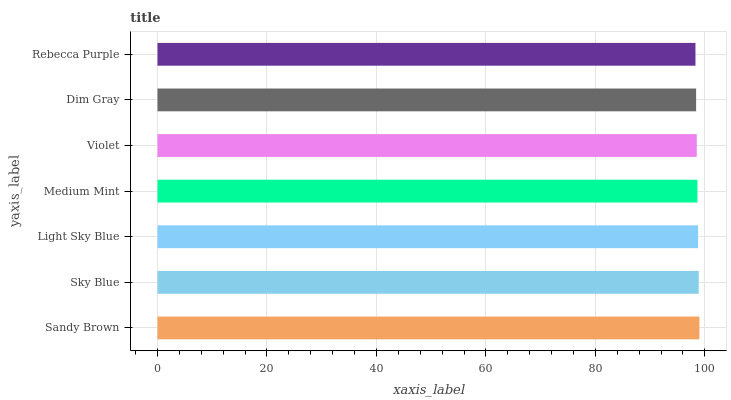Is Rebecca Purple the minimum?
Answer yes or no. Yes. Is Sandy Brown the maximum?
Answer yes or no. Yes. Is Sky Blue the minimum?
Answer yes or no. No. Is Sky Blue the maximum?
Answer yes or no. No. Is Sandy Brown greater than Sky Blue?
Answer yes or no. Yes. Is Sky Blue less than Sandy Brown?
Answer yes or no. Yes. Is Sky Blue greater than Sandy Brown?
Answer yes or no. No. Is Sandy Brown less than Sky Blue?
Answer yes or no. No. Is Medium Mint the high median?
Answer yes or no. Yes. Is Medium Mint the low median?
Answer yes or no. Yes. Is Rebecca Purple the high median?
Answer yes or no. No. Is Light Sky Blue the low median?
Answer yes or no. No. 